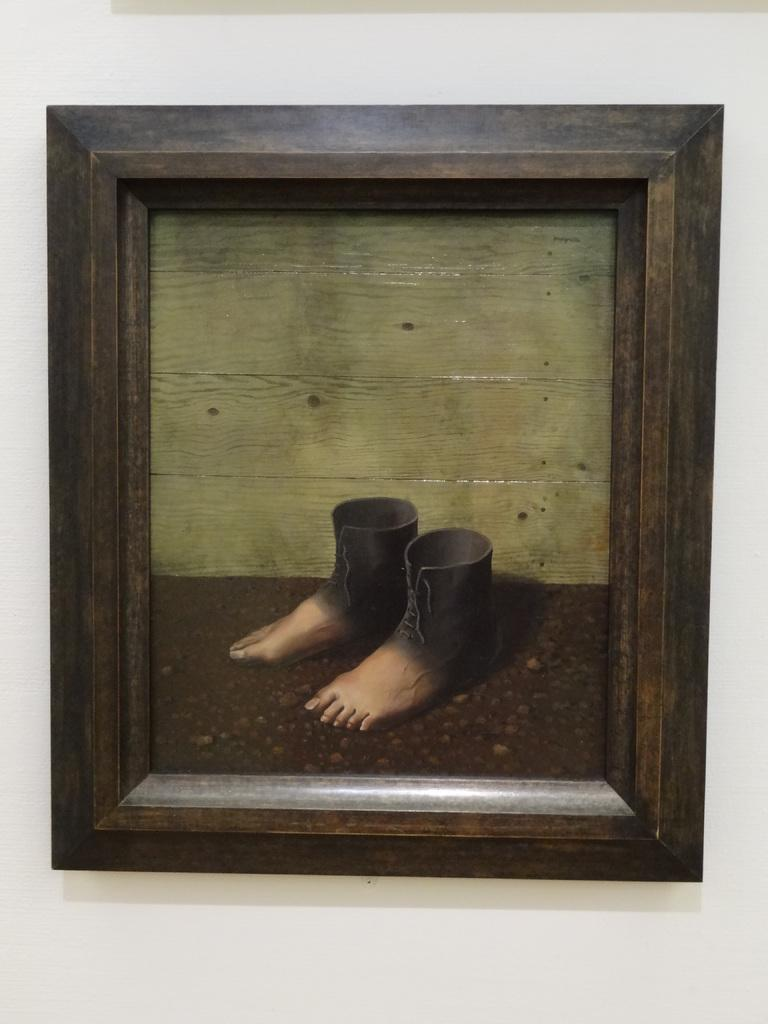What is attached to the wall in the image? There is a frame attached to the wall in the image. What color is the wall that the frame is attached to? The wall is painted white. What is inside the frame? There is a painting inside the frame. What type of pain can be seen in the image? There is no pain present in the image; it features a frame with a painting inside. Can you provide a suggestion for a new painting to be placed in the frame? The provided facts do not give enough information to suggest a new painting for the frame. 